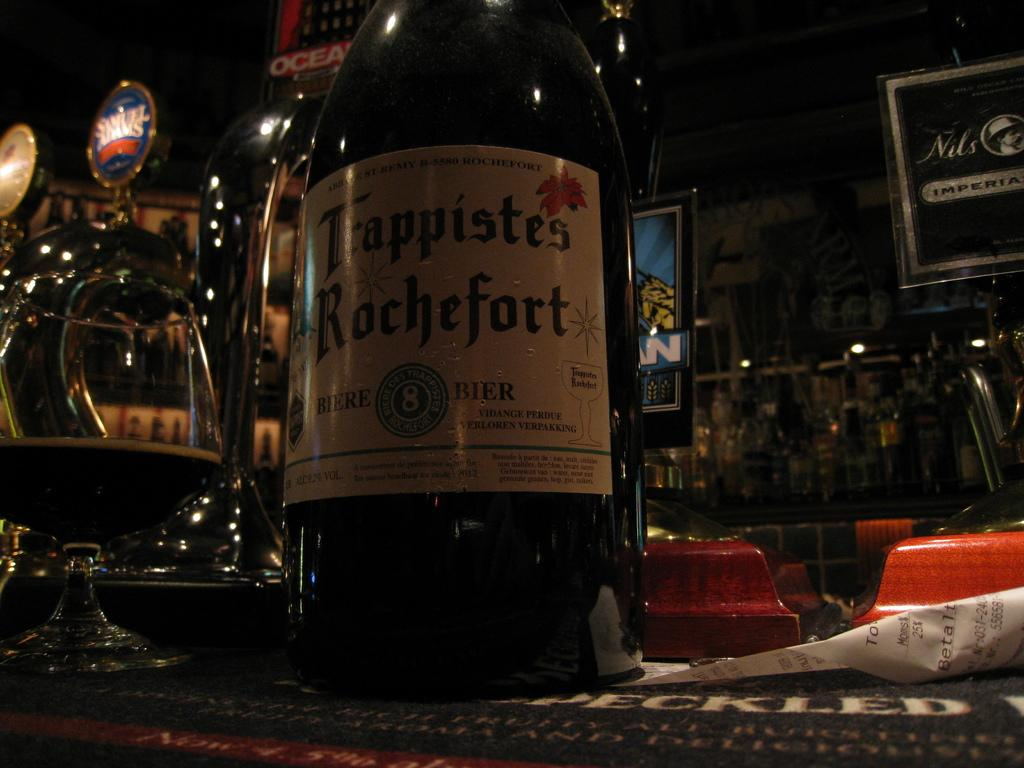<image>
Provide a brief description of the given image. the word Rochefort is on the bottle of alcohol 